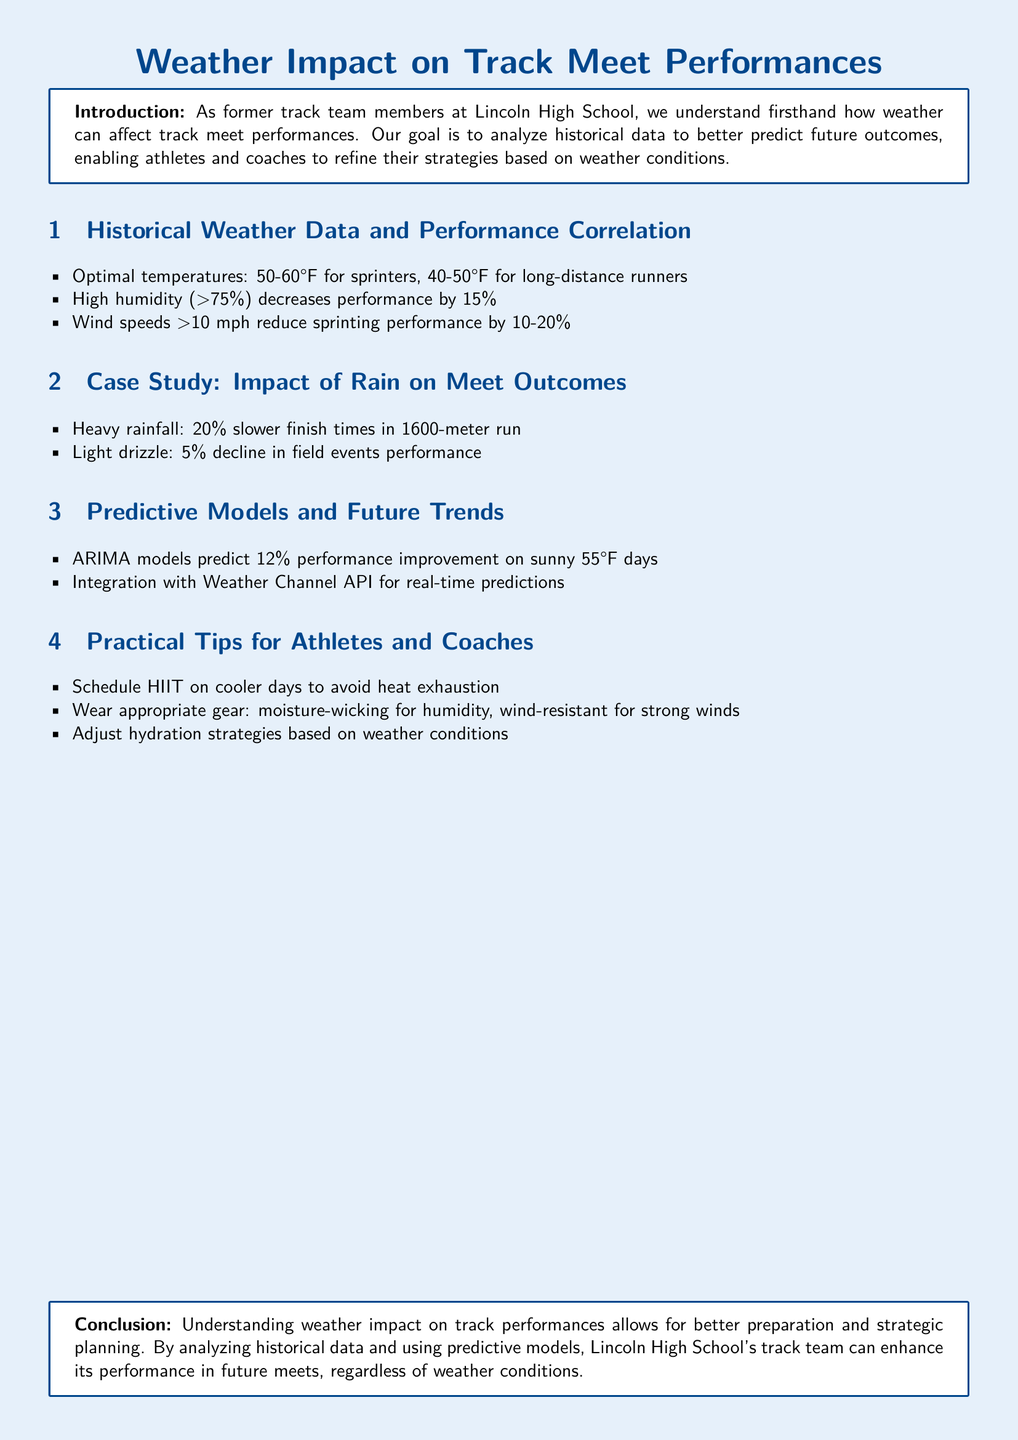What are optimal temperatures for sprinters? The document states that optimal temperatures for sprinters are between 50-60°F.
Answer: 50-60°F What is the impact of high humidity on performance? The document mentions that high humidity (>75%) decreases performance by 15%.
Answer: 15% How much slower do finish times become in heavy rainfall for the 1600-meter run? According to the document, heavy rainfall causes a 20% slower finish time in the 1600-meter run.
Answer: 20% What predictive model improvement can be expected on sunny 55°F days? The document states that ARIMA models predict a 12% performance improvement on sunny 55°F days.
Answer: 12% What specific gear is recommended for humidity? The document suggests wearing moisture-wicking gear for high humidity conditions.
Answer: Moisture-wicking How much does light drizzle impact field events performance? The document indicates that light drizzle causes a 5% decline in field events performance.
Answer: 5% What is the conclusion drawn about understanding weather impact? The conclusion states that understanding weather impact allows for better preparation and strategic planning.
Answer: Better preparation What is the effect of wind speeds over 10 mph on sprinting performance? The document explains that wind speeds over 10 mph reduce sprinting performance by 10-20%.
Answer: 10-20% What tool is mentioned for integrating real-time predictions? The document references the Weather Channel API for integration with real-time predictions.
Answer: Weather Channel API 